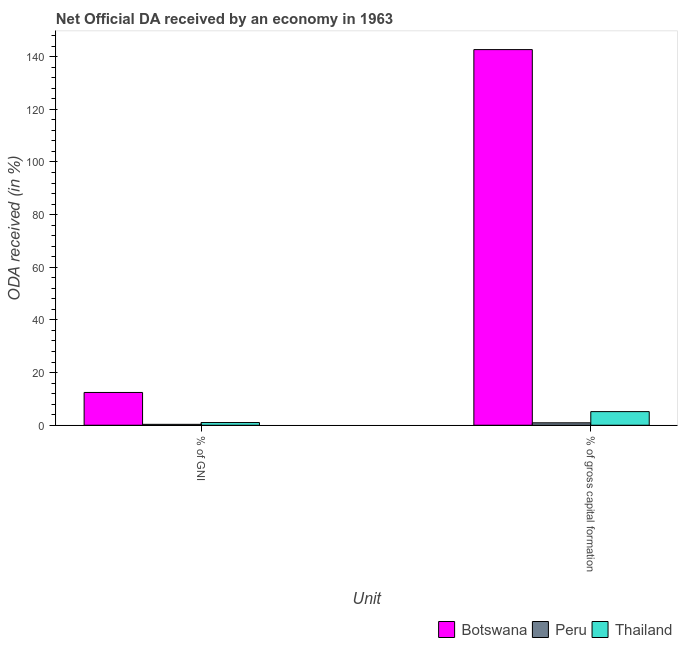How many different coloured bars are there?
Your answer should be very brief. 3. Are the number of bars per tick equal to the number of legend labels?
Make the answer very short. Yes. How many bars are there on the 1st tick from the left?
Offer a very short reply. 3. What is the label of the 2nd group of bars from the left?
Your answer should be very brief. % of gross capital formation. What is the oda received as percentage of gni in Botswana?
Provide a succinct answer. 12.45. Across all countries, what is the maximum oda received as percentage of gross capital formation?
Ensure brevity in your answer.  142.68. Across all countries, what is the minimum oda received as percentage of gross capital formation?
Make the answer very short. 0.92. In which country was the oda received as percentage of gni maximum?
Keep it short and to the point. Botswana. What is the total oda received as percentage of gross capital formation in the graph?
Your answer should be very brief. 148.77. What is the difference between the oda received as percentage of gross capital formation in Botswana and that in Thailand?
Your answer should be very brief. 137.5. What is the difference between the oda received as percentage of gross capital formation in Thailand and the oda received as percentage of gni in Botswana?
Keep it short and to the point. -7.27. What is the average oda received as percentage of gross capital formation per country?
Give a very brief answer. 49.59. What is the difference between the oda received as percentage of gni and oda received as percentage of gross capital formation in Thailand?
Provide a short and direct response. -4.15. In how many countries, is the oda received as percentage of gross capital formation greater than 72 %?
Keep it short and to the point. 1. What is the ratio of the oda received as percentage of gni in Botswana to that in Thailand?
Offer a terse response. 12.11. Is the oda received as percentage of gni in Peru less than that in Botswana?
Your response must be concise. Yes. In how many countries, is the oda received as percentage of gross capital formation greater than the average oda received as percentage of gross capital formation taken over all countries?
Offer a terse response. 1. What does the 2nd bar from the left in % of gross capital formation represents?
Provide a succinct answer. Peru. What does the 1st bar from the right in % of GNI represents?
Provide a short and direct response. Thailand. How many countries are there in the graph?
Provide a short and direct response. 3. What is the difference between two consecutive major ticks on the Y-axis?
Offer a very short reply. 20. Are the values on the major ticks of Y-axis written in scientific E-notation?
Keep it short and to the point. No. Does the graph contain grids?
Provide a short and direct response. No. What is the title of the graph?
Keep it short and to the point. Net Official DA received by an economy in 1963. Does "Sudan" appear as one of the legend labels in the graph?
Your answer should be very brief. No. What is the label or title of the X-axis?
Provide a succinct answer. Unit. What is the label or title of the Y-axis?
Your answer should be compact. ODA received (in %). What is the ODA received (in %) of Botswana in % of GNI?
Give a very brief answer. 12.45. What is the ODA received (in %) of Peru in % of GNI?
Your response must be concise. 0.35. What is the ODA received (in %) of Thailand in % of GNI?
Ensure brevity in your answer.  1.03. What is the ODA received (in %) in Botswana in % of gross capital formation?
Offer a very short reply. 142.68. What is the ODA received (in %) in Peru in % of gross capital formation?
Your answer should be very brief. 0.92. What is the ODA received (in %) of Thailand in % of gross capital formation?
Provide a succinct answer. 5.18. Across all Unit, what is the maximum ODA received (in %) of Botswana?
Your answer should be very brief. 142.68. Across all Unit, what is the maximum ODA received (in %) of Peru?
Give a very brief answer. 0.92. Across all Unit, what is the maximum ODA received (in %) in Thailand?
Provide a short and direct response. 5.18. Across all Unit, what is the minimum ODA received (in %) of Botswana?
Offer a terse response. 12.45. Across all Unit, what is the minimum ODA received (in %) in Peru?
Your response must be concise. 0.35. Across all Unit, what is the minimum ODA received (in %) in Thailand?
Make the answer very short. 1.03. What is the total ODA received (in %) in Botswana in the graph?
Your response must be concise. 155.13. What is the total ODA received (in %) in Peru in the graph?
Your answer should be compact. 1.26. What is the total ODA received (in %) in Thailand in the graph?
Provide a succinct answer. 6.2. What is the difference between the ODA received (in %) of Botswana in % of GNI and that in % of gross capital formation?
Offer a very short reply. -130.23. What is the difference between the ODA received (in %) in Peru in % of GNI and that in % of gross capital formation?
Ensure brevity in your answer.  -0.57. What is the difference between the ODA received (in %) of Thailand in % of GNI and that in % of gross capital formation?
Provide a succinct answer. -4.15. What is the difference between the ODA received (in %) in Botswana in % of GNI and the ODA received (in %) in Peru in % of gross capital formation?
Give a very brief answer. 11.53. What is the difference between the ODA received (in %) in Botswana in % of GNI and the ODA received (in %) in Thailand in % of gross capital formation?
Your response must be concise. 7.27. What is the difference between the ODA received (in %) of Peru in % of GNI and the ODA received (in %) of Thailand in % of gross capital formation?
Offer a very short reply. -4.83. What is the average ODA received (in %) of Botswana per Unit?
Ensure brevity in your answer.  77.56. What is the average ODA received (in %) of Peru per Unit?
Make the answer very short. 0.63. What is the average ODA received (in %) in Thailand per Unit?
Your answer should be compact. 3.1. What is the difference between the ODA received (in %) of Botswana and ODA received (in %) of Peru in % of GNI?
Give a very brief answer. 12.1. What is the difference between the ODA received (in %) of Botswana and ODA received (in %) of Thailand in % of GNI?
Offer a terse response. 11.42. What is the difference between the ODA received (in %) in Peru and ODA received (in %) in Thailand in % of GNI?
Offer a terse response. -0.68. What is the difference between the ODA received (in %) of Botswana and ODA received (in %) of Peru in % of gross capital formation?
Your answer should be very brief. 141.76. What is the difference between the ODA received (in %) of Botswana and ODA received (in %) of Thailand in % of gross capital formation?
Provide a succinct answer. 137.5. What is the difference between the ODA received (in %) in Peru and ODA received (in %) in Thailand in % of gross capital formation?
Offer a very short reply. -4.26. What is the ratio of the ODA received (in %) in Botswana in % of GNI to that in % of gross capital formation?
Your answer should be very brief. 0.09. What is the ratio of the ODA received (in %) in Peru in % of GNI to that in % of gross capital formation?
Your response must be concise. 0.38. What is the ratio of the ODA received (in %) of Thailand in % of GNI to that in % of gross capital formation?
Keep it short and to the point. 0.2. What is the difference between the highest and the second highest ODA received (in %) of Botswana?
Your response must be concise. 130.23. What is the difference between the highest and the second highest ODA received (in %) of Peru?
Your answer should be compact. 0.57. What is the difference between the highest and the second highest ODA received (in %) in Thailand?
Give a very brief answer. 4.15. What is the difference between the highest and the lowest ODA received (in %) of Botswana?
Make the answer very short. 130.23. What is the difference between the highest and the lowest ODA received (in %) of Peru?
Make the answer very short. 0.57. What is the difference between the highest and the lowest ODA received (in %) in Thailand?
Provide a short and direct response. 4.15. 